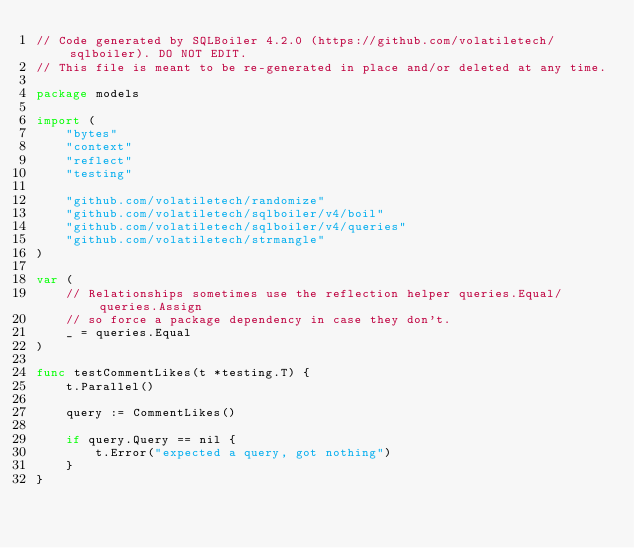<code> <loc_0><loc_0><loc_500><loc_500><_Go_>// Code generated by SQLBoiler 4.2.0 (https://github.com/volatiletech/sqlboiler). DO NOT EDIT.
// This file is meant to be re-generated in place and/or deleted at any time.

package models

import (
	"bytes"
	"context"
	"reflect"
	"testing"

	"github.com/volatiletech/randomize"
	"github.com/volatiletech/sqlboiler/v4/boil"
	"github.com/volatiletech/sqlboiler/v4/queries"
	"github.com/volatiletech/strmangle"
)

var (
	// Relationships sometimes use the reflection helper queries.Equal/queries.Assign
	// so force a package dependency in case they don't.
	_ = queries.Equal
)

func testCommentLikes(t *testing.T) {
	t.Parallel()

	query := CommentLikes()

	if query.Query == nil {
		t.Error("expected a query, got nothing")
	}
}
</code> 